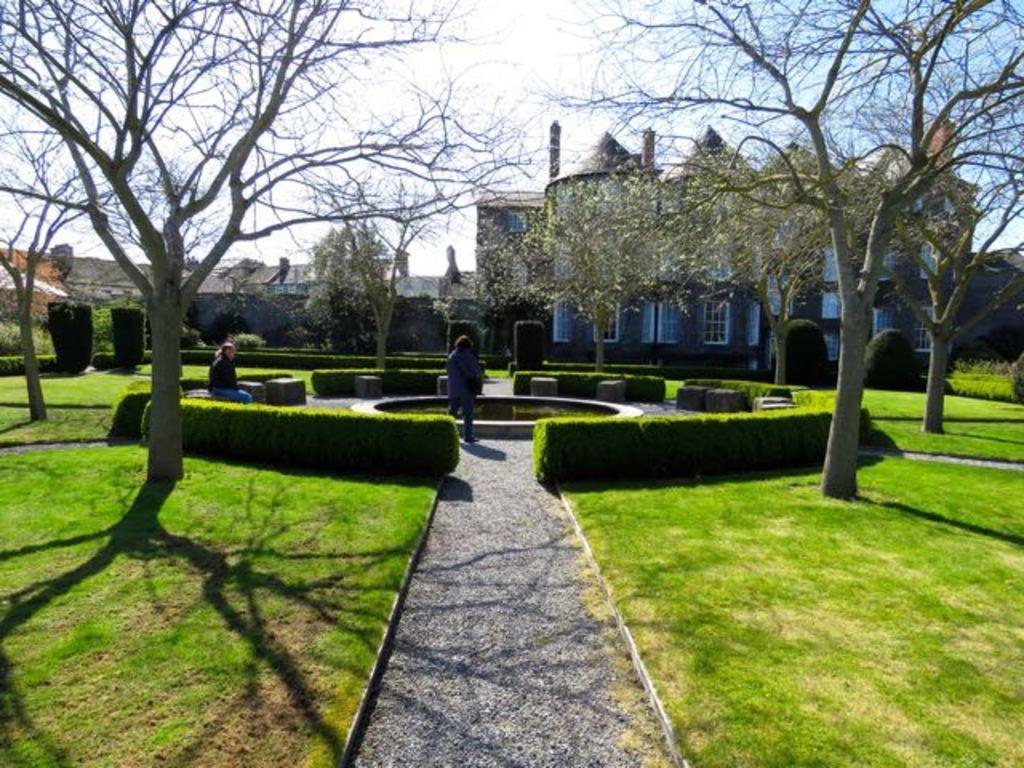Could you give a brief overview of what you see in this image? In this image in the front there's grass on the ground. In the center there are persons standing and sitting, there are plants and trees. In the background there are buildings and the sky is cloudy and there are plants. 